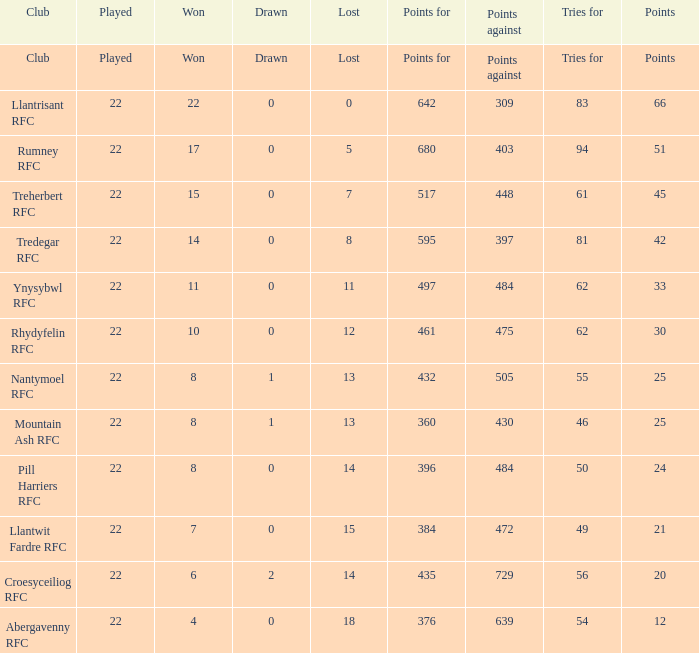How many matches were drawn by the teams that won exactly 10? 1.0. 